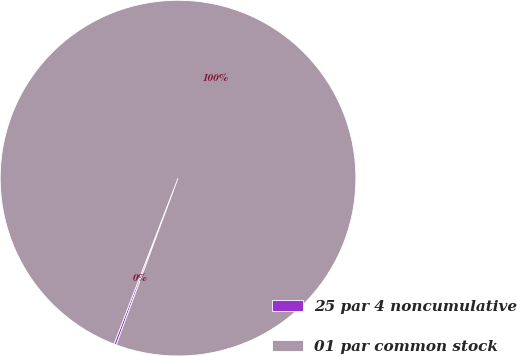<chart> <loc_0><loc_0><loc_500><loc_500><pie_chart><fcel>25 par 4 noncumulative<fcel>01 par common stock<nl><fcel>0.21%<fcel>99.79%<nl></chart> 